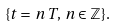Convert formula to latex. <formula><loc_0><loc_0><loc_500><loc_500>\{ t = \, n \, T , \, n \in \mathbb { Z } \} .</formula> 